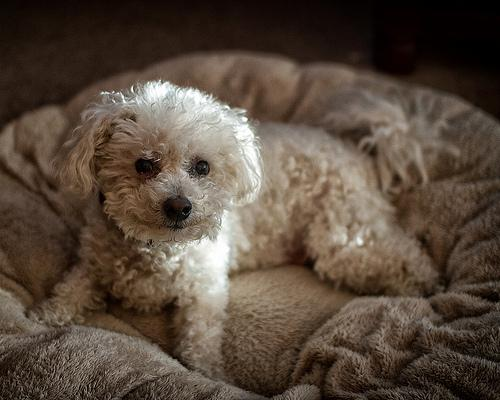Question: what animal is this?
Choices:
A. Dog.
B. Wolf.
C. Cat.
D. Lion.
Answer with the letter. Answer: A Question: why is the dog dirty?
Choices:
A. The mud.
B. The rain.
C. The ground.
D. He needs a bath.
Answer with the letter. Answer: D Question: who is sleeping?
Choices:
A. The cat.
B. No one.
C. The lion.
D. The person.
Answer with the letter. Answer: B Question: how many people are there?
Choices:
A. 0.
B. 9.
C. 5.
D. 4.
Answer with the letter. Answer: A Question: what color is the bed?
Choices:
A. White.
B. Black.
C. Blue.
D. Beige.
Answer with the letter. Answer: D 